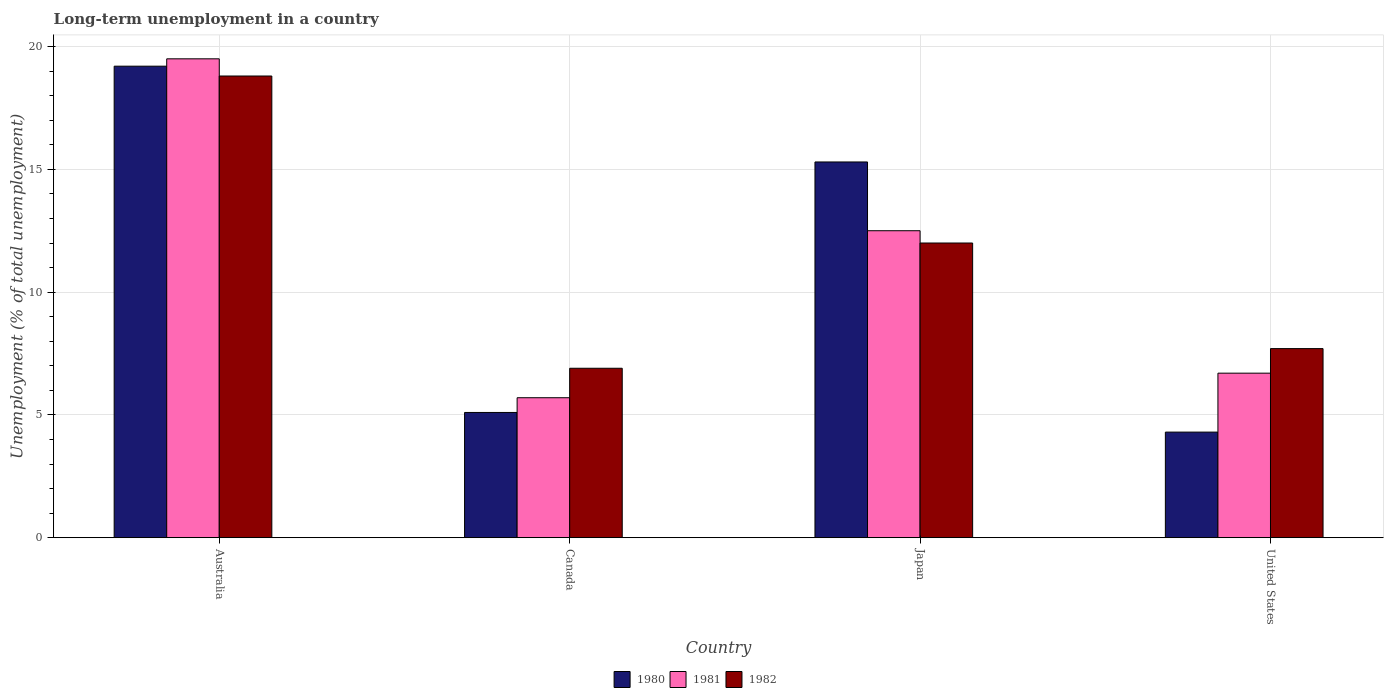How many groups of bars are there?
Give a very brief answer. 4. Are the number of bars per tick equal to the number of legend labels?
Your answer should be very brief. Yes. In how many cases, is the number of bars for a given country not equal to the number of legend labels?
Provide a short and direct response. 0. What is the percentage of long-term unemployed population in 1981 in Canada?
Make the answer very short. 5.7. Across all countries, what is the minimum percentage of long-term unemployed population in 1982?
Keep it short and to the point. 6.9. In which country was the percentage of long-term unemployed population in 1981 minimum?
Provide a succinct answer. Canada. What is the total percentage of long-term unemployed population in 1980 in the graph?
Keep it short and to the point. 43.9. What is the difference between the percentage of long-term unemployed population in 1980 in Canada and that in Japan?
Provide a short and direct response. -10.2. What is the difference between the percentage of long-term unemployed population in 1980 in Canada and the percentage of long-term unemployed population in 1981 in United States?
Ensure brevity in your answer.  -1.6. What is the average percentage of long-term unemployed population in 1982 per country?
Provide a short and direct response. 11.35. What is the difference between the percentage of long-term unemployed population of/in 1981 and percentage of long-term unemployed population of/in 1982 in Japan?
Ensure brevity in your answer.  0.5. In how many countries, is the percentage of long-term unemployed population in 1982 greater than 5 %?
Give a very brief answer. 4. What is the ratio of the percentage of long-term unemployed population in 1982 in Australia to that in United States?
Make the answer very short. 2.44. Is the percentage of long-term unemployed population in 1980 in Australia less than that in Canada?
Offer a terse response. No. What is the difference between the highest and the second highest percentage of long-term unemployed population in 1982?
Offer a terse response. 6.8. What is the difference between the highest and the lowest percentage of long-term unemployed population in 1981?
Your answer should be very brief. 13.8. In how many countries, is the percentage of long-term unemployed population in 1982 greater than the average percentage of long-term unemployed population in 1982 taken over all countries?
Offer a very short reply. 2. What does the 3rd bar from the left in United States represents?
Offer a terse response. 1982. Is it the case that in every country, the sum of the percentage of long-term unemployed population in 1981 and percentage of long-term unemployed population in 1980 is greater than the percentage of long-term unemployed population in 1982?
Your answer should be compact. Yes. Are all the bars in the graph horizontal?
Offer a very short reply. No. Does the graph contain any zero values?
Provide a short and direct response. No. Does the graph contain grids?
Ensure brevity in your answer.  Yes. How many legend labels are there?
Provide a short and direct response. 3. How are the legend labels stacked?
Your answer should be compact. Horizontal. What is the title of the graph?
Keep it short and to the point. Long-term unemployment in a country. Does "1980" appear as one of the legend labels in the graph?
Provide a succinct answer. Yes. What is the label or title of the X-axis?
Give a very brief answer. Country. What is the label or title of the Y-axis?
Make the answer very short. Unemployment (% of total unemployment). What is the Unemployment (% of total unemployment) in 1980 in Australia?
Give a very brief answer. 19.2. What is the Unemployment (% of total unemployment) of 1982 in Australia?
Your answer should be compact. 18.8. What is the Unemployment (% of total unemployment) in 1980 in Canada?
Offer a very short reply. 5.1. What is the Unemployment (% of total unemployment) in 1981 in Canada?
Your answer should be very brief. 5.7. What is the Unemployment (% of total unemployment) of 1982 in Canada?
Provide a succinct answer. 6.9. What is the Unemployment (% of total unemployment) of 1980 in Japan?
Make the answer very short. 15.3. What is the Unemployment (% of total unemployment) of 1982 in Japan?
Give a very brief answer. 12. What is the Unemployment (% of total unemployment) in 1980 in United States?
Your answer should be compact. 4.3. What is the Unemployment (% of total unemployment) of 1981 in United States?
Keep it short and to the point. 6.7. What is the Unemployment (% of total unemployment) in 1982 in United States?
Offer a terse response. 7.7. Across all countries, what is the maximum Unemployment (% of total unemployment) of 1980?
Your response must be concise. 19.2. Across all countries, what is the maximum Unemployment (% of total unemployment) of 1981?
Keep it short and to the point. 19.5. Across all countries, what is the maximum Unemployment (% of total unemployment) in 1982?
Offer a terse response. 18.8. Across all countries, what is the minimum Unemployment (% of total unemployment) of 1980?
Provide a short and direct response. 4.3. Across all countries, what is the minimum Unemployment (% of total unemployment) in 1981?
Give a very brief answer. 5.7. Across all countries, what is the minimum Unemployment (% of total unemployment) in 1982?
Provide a succinct answer. 6.9. What is the total Unemployment (% of total unemployment) in 1980 in the graph?
Your response must be concise. 43.9. What is the total Unemployment (% of total unemployment) of 1981 in the graph?
Offer a very short reply. 44.4. What is the total Unemployment (% of total unemployment) of 1982 in the graph?
Provide a short and direct response. 45.4. What is the difference between the Unemployment (% of total unemployment) in 1980 in Australia and that in Canada?
Ensure brevity in your answer.  14.1. What is the difference between the Unemployment (% of total unemployment) of 1981 in Australia and that in Canada?
Your answer should be compact. 13.8. What is the difference between the Unemployment (% of total unemployment) of 1982 in Australia and that in Canada?
Provide a succinct answer. 11.9. What is the difference between the Unemployment (% of total unemployment) in 1980 in Australia and that in Japan?
Ensure brevity in your answer.  3.9. What is the difference between the Unemployment (% of total unemployment) of 1981 in Australia and that in United States?
Your response must be concise. 12.8. What is the difference between the Unemployment (% of total unemployment) in 1982 in Australia and that in United States?
Make the answer very short. 11.1. What is the difference between the Unemployment (% of total unemployment) of 1980 in Canada and that in Japan?
Provide a succinct answer. -10.2. What is the difference between the Unemployment (% of total unemployment) of 1981 in Canada and that in Japan?
Your response must be concise. -6.8. What is the difference between the Unemployment (% of total unemployment) in 1981 in Canada and that in United States?
Offer a very short reply. -1. What is the difference between the Unemployment (% of total unemployment) in 1982 in Canada and that in United States?
Offer a very short reply. -0.8. What is the difference between the Unemployment (% of total unemployment) in 1982 in Japan and that in United States?
Make the answer very short. 4.3. What is the difference between the Unemployment (% of total unemployment) of 1980 in Australia and the Unemployment (% of total unemployment) of 1982 in Canada?
Your answer should be very brief. 12.3. What is the difference between the Unemployment (% of total unemployment) in 1981 in Australia and the Unemployment (% of total unemployment) in 1982 in Canada?
Your answer should be compact. 12.6. What is the difference between the Unemployment (% of total unemployment) in 1980 in Australia and the Unemployment (% of total unemployment) in 1981 in Japan?
Keep it short and to the point. 6.7. What is the difference between the Unemployment (% of total unemployment) in 1980 in Australia and the Unemployment (% of total unemployment) in 1982 in Japan?
Ensure brevity in your answer.  7.2. What is the difference between the Unemployment (% of total unemployment) of 1981 in Australia and the Unemployment (% of total unemployment) of 1982 in Japan?
Your answer should be very brief. 7.5. What is the difference between the Unemployment (% of total unemployment) of 1980 in Australia and the Unemployment (% of total unemployment) of 1982 in United States?
Ensure brevity in your answer.  11.5. What is the difference between the Unemployment (% of total unemployment) in 1980 in Canada and the Unemployment (% of total unemployment) in 1981 in Japan?
Offer a very short reply. -7.4. What is the difference between the Unemployment (% of total unemployment) of 1980 in Canada and the Unemployment (% of total unemployment) of 1982 in Japan?
Your answer should be very brief. -6.9. What is the difference between the Unemployment (% of total unemployment) of 1980 in Canada and the Unemployment (% of total unemployment) of 1982 in United States?
Keep it short and to the point. -2.6. What is the difference between the Unemployment (% of total unemployment) of 1981 in Canada and the Unemployment (% of total unemployment) of 1982 in United States?
Your answer should be compact. -2. What is the difference between the Unemployment (% of total unemployment) of 1980 in Japan and the Unemployment (% of total unemployment) of 1981 in United States?
Offer a terse response. 8.6. What is the difference between the Unemployment (% of total unemployment) in 1981 in Japan and the Unemployment (% of total unemployment) in 1982 in United States?
Provide a succinct answer. 4.8. What is the average Unemployment (% of total unemployment) in 1980 per country?
Your answer should be compact. 10.97. What is the average Unemployment (% of total unemployment) in 1981 per country?
Keep it short and to the point. 11.1. What is the average Unemployment (% of total unemployment) in 1982 per country?
Offer a very short reply. 11.35. What is the difference between the Unemployment (% of total unemployment) in 1981 and Unemployment (% of total unemployment) in 1982 in Australia?
Your response must be concise. 0.7. What is the difference between the Unemployment (% of total unemployment) in 1980 and Unemployment (% of total unemployment) in 1982 in Canada?
Provide a succinct answer. -1.8. What is the difference between the Unemployment (% of total unemployment) of 1980 and Unemployment (% of total unemployment) of 1981 in Japan?
Ensure brevity in your answer.  2.8. What is the difference between the Unemployment (% of total unemployment) in 1981 and Unemployment (% of total unemployment) in 1982 in Japan?
Offer a terse response. 0.5. What is the difference between the Unemployment (% of total unemployment) of 1980 and Unemployment (% of total unemployment) of 1981 in United States?
Provide a short and direct response. -2.4. What is the ratio of the Unemployment (% of total unemployment) of 1980 in Australia to that in Canada?
Your answer should be compact. 3.76. What is the ratio of the Unemployment (% of total unemployment) of 1981 in Australia to that in Canada?
Your answer should be compact. 3.42. What is the ratio of the Unemployment (% of total unemployment) in 1982 in Australia to that in Canada?
Make the answer very short. 2.72. What is the ratio of the Unemployment (% of total unemployment) of 1980 in Australia to that in Japan?
Offer a very short reply. 1.25. What is the ratio of the Unemployment (% of total unemployment) of 1981 in Australia to that in Japan?
Keep it short and to the point. 1.56. What is the ratio of the Unemployment (% of total unemployment) of 1982 in Australia to that in Japan?
Your answer should be compact. 1.57. What is the ratio of the Unemployment (% of total unemployment) in 1980 in Australia to that in United States?
Provide a short and direct response. 4.47. What is the ratio of the Unemployment (% of total unemployment) in 1981 in Australia to that in United States?
Offer a very short reply. 2.91. What is the ratio of the Unemployment (% of total unemployment) in 1982 in Australia to that in United States?
Your answer should be very brief. 2.44. What is the ratio of the Unemployment (% of total unemployment) in 1981 in Canada to that in Japan?
Make the answer very short. 0.46. What is the ratio of the Unemployment (% of total unemployment) in 1982 in Canada to that in Japan?
Ensure brevity in your answer.  0.57. What is the ratio of the Unemployment (% of total unemployment) of 1980 in Canada to that in United States?
Give a very brief answer. 1.19. What is the ratio of the Unemployment (% of total unemployment) of 1981 in Canada to that in United States?
Offer a terse response. 0.85. What is the ratio of the Unemployment (% of total unemployment) in 1982 in Canada to that in United States?
Your answer should be compact. 0.9. What is the ratio of the Unemployment (% of total unemployment) of 1980 in Japan to that in United States?
Offer a terse response. 3.56. What is the ratio of the Unemployment (% of total unemployment) of 1981 in Japan to that in United States?
Provide a succinct answer. 1.87. What is the ratio of the Unemployment (% of total unemployment) of 1982 in Japan to that in United States?
Your response must be concise. 1.56. What is the difference between the highest and the second highest Unemployment (% of total unemployment) in 1980?
Provide a succinct answer. 3.9. 